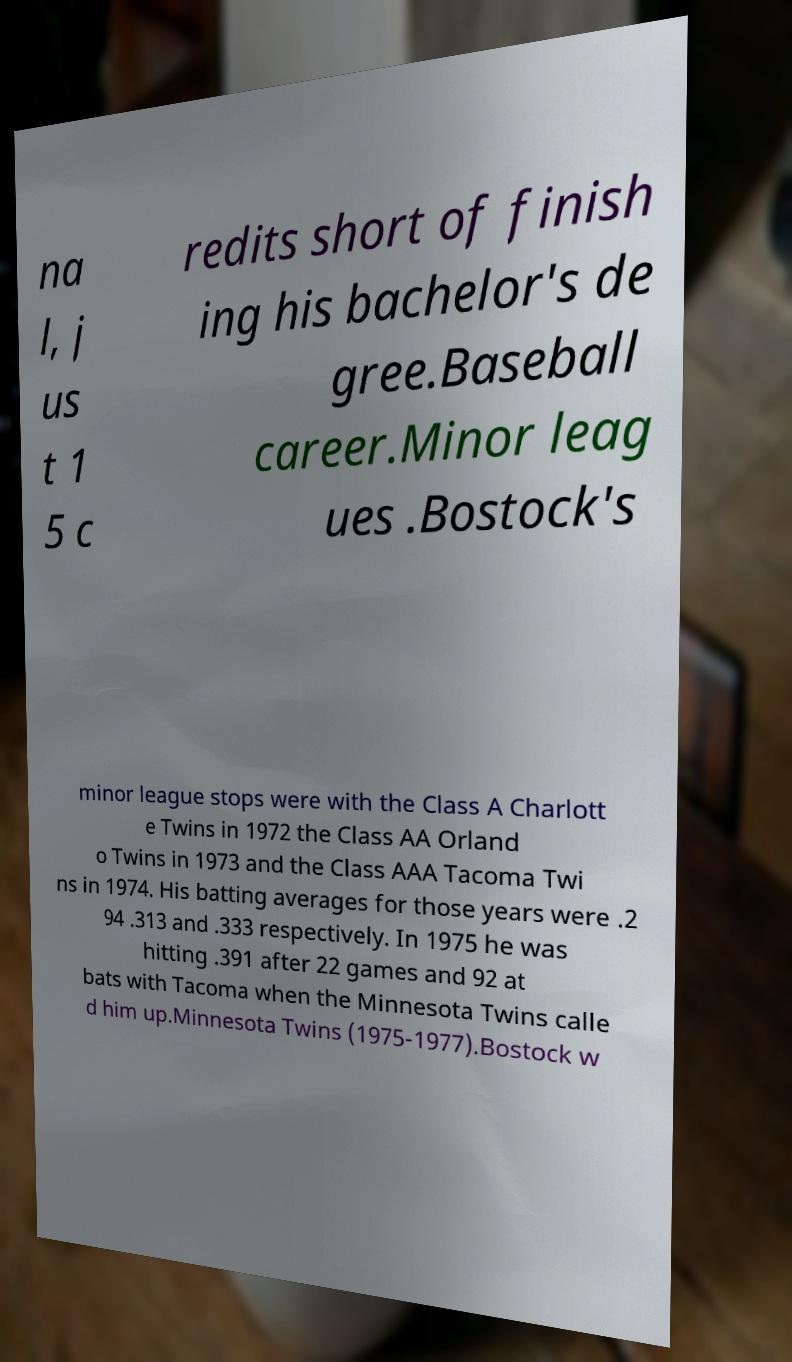What messages or text are displayed in this image? I need them in a readable, typed format. na l, j us t 1 5 c redits short of finish ing his bachelor's de gree.Baseball career.Minor leag ues .Bostock's minor league stops were with the Class A Charlott e Twins in 1972 the Class AA Orland o Twins in 1973 and the Class AAA Tacoma Twi ns in 1974. His batting averages for those years were .2 94 .313 and .333 respectively. In 1975 he was hitting .391 after 22 games and 92 at bats with Tacoma when the Minnesota Twins calle d him up.Minnesota Twins (1975-1977).Bostock w 